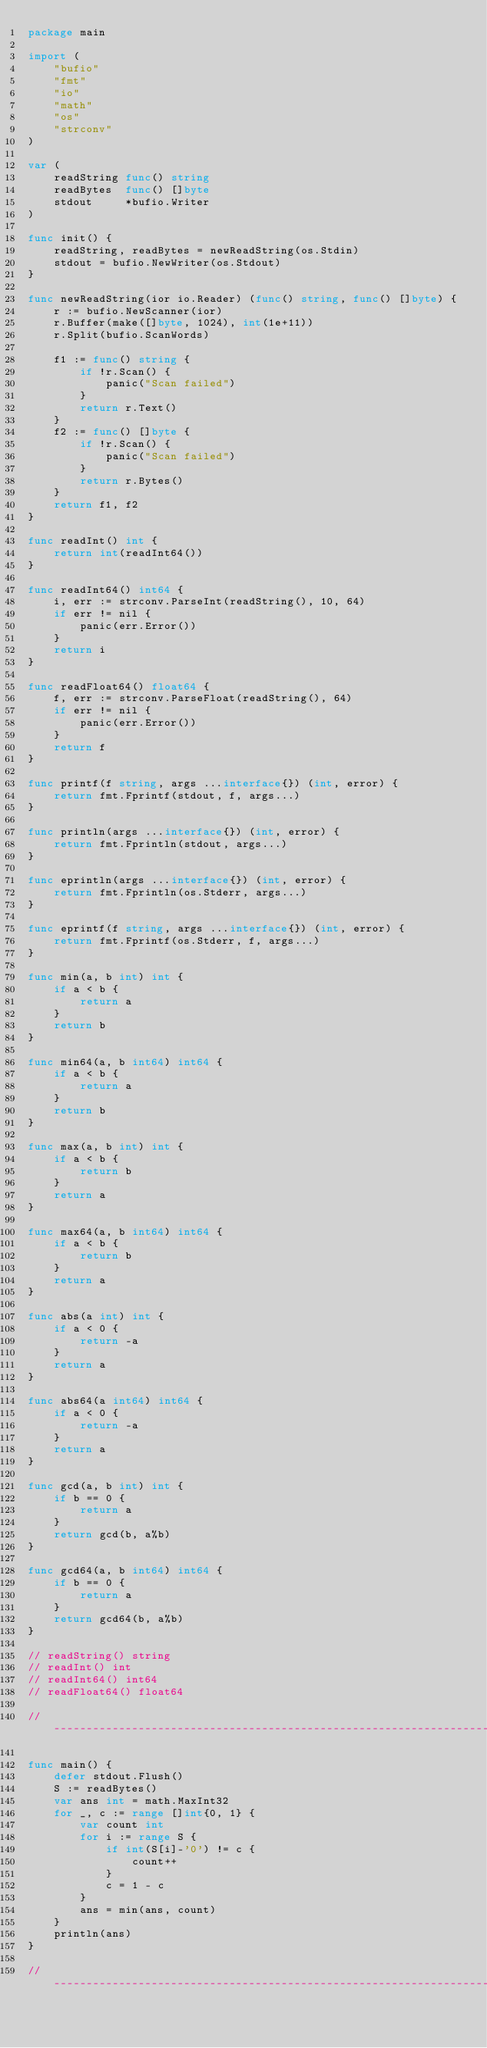<code> <loc_0><loc_0><loc_500><loc_500><_Go_>package main

import (
	"bufio"
	"fmt"
	"io"
	"math"
	"os"
	"strconv"
)

var (
	readString func() string
	readBytes  func() []byte
	stdout     *bufio.Writer
)

func init() {
	readString, readBytes = newReadString(os.Stdin)
	stdout = bufio.NewWriter(os.Stdout)
}

func newReadString(ior io.Reader) (func() string, func() []byte) {
	r := bufio.NewScanner(ior)
	r.Buffer(make([]byte, 1024), int(1e+11))
	r.Split(bufio.ScanWords)

	f1 := func() string {
		if !r.Scan() {
			panic("Scan failed")
		}
		return r.Text()
	}
	f2 := func() []byte {
		if !r.Scan() {
			panic("Scan failed")
		}
		return r.Bytes()
	}
	return f1, f2
}

func readInt() int {
	return int(readInt64())
}

func readInt64() int64 {
	i, err := strconv.ParseInt(readString(), 10, 64)
	if err != nil {
		panic(err.Error())
	}
	return i
}

func readFloat64() float64 {
	f, err := strconv.ParseFloat(readString(), 64)
	if err != nil {
		panic(err.Error())
	}
	return f
}

func printf(f string, args ...interface{}) (int, error) {
	return fmt.Fprintf(stdout, f, args...)
}

func println(args ...interface{}) (int, error) {
	return fmt.Fprintln(stdout, args...)
}

func eprintln(args ...interface{}) (int, error) {
	return fmt.Fprintln(os.Stderr, args...)
}

func eprintf(f string, args ...interface{}) (int, error) {
	return fmt.Fprintf(os.Stderr, f, args...)
}

func min(a, b int) int {
	if a < b {
		return a
	}
	return b
}

func min64(a, b int64) int64 {
	if a < b {
		return a
	}
	return b
}

func max(a, b int) int {
	if a < b {
		return b
	}
	return a
}

func max64(a, b int64) int64 {
	if a < b {
		return b
	}
	return a
}

func abs(a int) int {
	if a < 0 {
		return -a
	}
	return a
}

func abs64(a int64) int64 {
	if a < 0 {
		return -a
	}
	return a
}

func gcd(a, b int) int {
	if b == 0 {
		return a
	}
	return gcd(b, a%b)
}

func gcd64(a, b int64) int64 {
	if b == 0 {
		return a
	}
	return gcd64(b, a%b)
}

// readString() string
// readInt() int
// readInt64() int64
// readFloat64() float64

// -----------------------------------------------------------------------------

func main() {
	defer stdout.Flush()
	S := readBytes()
	var ans int = math.MaxInt32
	for _, c := range []int{0, 1} {
		var count int
		for i := range S {
			if int(S[i]-'0') != c {
				count++
			}
			c = 1 - c
		}
		ans = min(ans, count)
	}
	println(ans)
}

// -----------------------------------------------------------------------------
</code> 